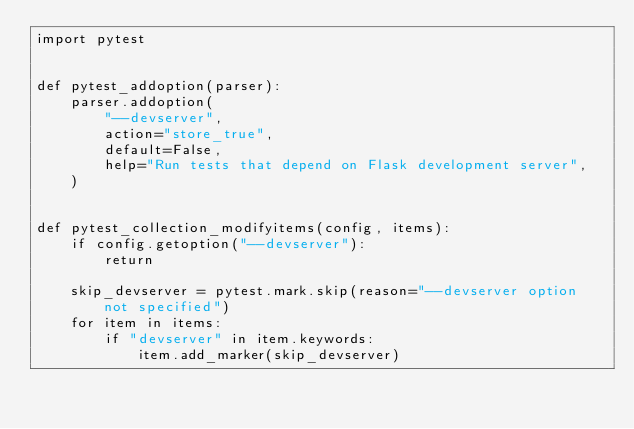Convert code to text. <code><loc_0><loc_0><loc_500><loc_500><_Python_>import pytest


def pytest_addoption(parser):
    parser.addoption(
        "--devserver",
        action="store_true",
        default=False,
        help="Run tests that depend on Flask development server",
    )


def pytest_collection_modifyitems(config, items):
    if config.getoption("--devserver"):
        return

    skip_devserver = pytest.mark.skip(reason="--devserver option not specified")
    for item in items:
        if "devserver" in item.keywords:
            item.add_marker(skip_devserver)
</code> 